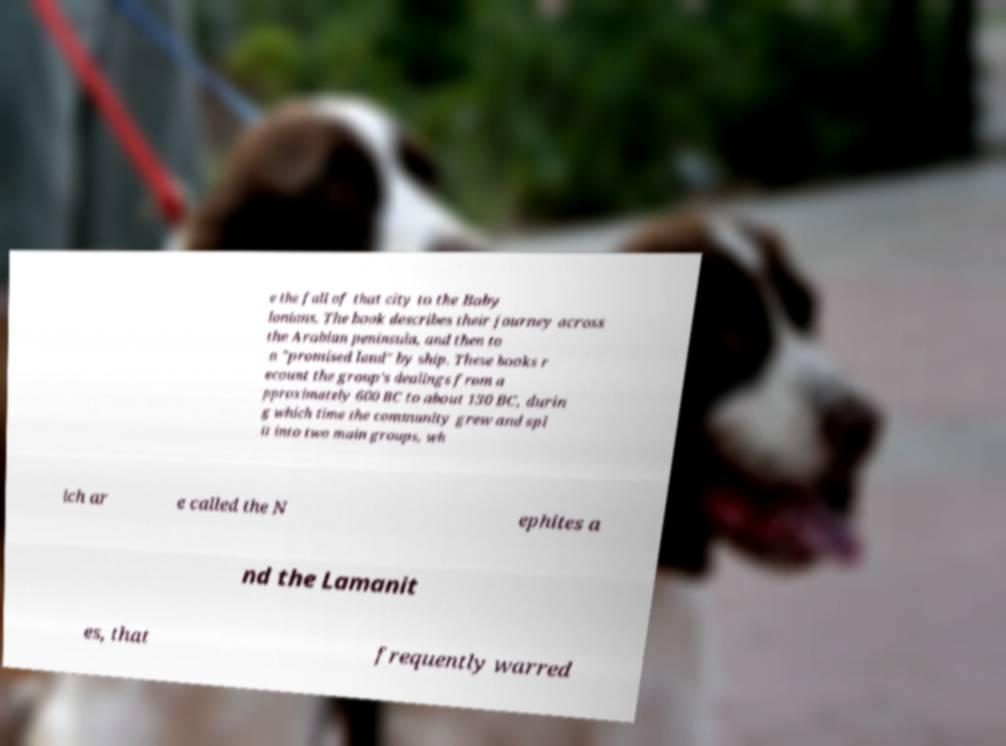I need the written content from this picture converted into text. Can you do that? e the fall of that city to the Baby lonians. The book describes their journey across the Arabian peninsula, and then to a "promised land" by ship. These books r ecount the group's dealings from a pproximately 600 BC to about 130 BC, durin g which time the community grew and spl it into two main groups, wh ich ar e called the N ephites a nd the Lamanit es, that frequently warred 